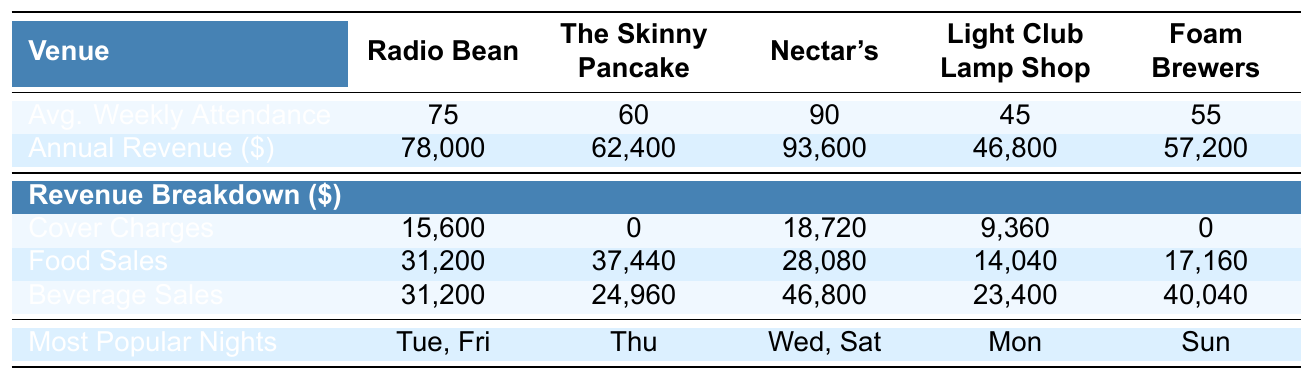What is the average weekly attendance at Nectar's? According to the table, the average weekly attendance for Nectar's is listed as 90 people.
Answer: 90 Which venue has the highest annual revenue? By comparing the annual revenue values listed in the table, Nectar's has the highest annual revenue at $93,600.
Answer: Nectar's How much revenue does Radio Bean make from food sales? The table indicates that Radio Bean generates $31,200 from food sales.
Answer: $31,200 Does The Skinny Pancake have revenue from cover charges? The data states that The Skinny Pancake has $0 in cover charges, indicating they do not collect any revenue from this source.
Answer: No What is the total beverage sales across all venues? To find the total beverage sales, we sum the values: 31,200 (Radio Bean) + 24,960 (The Skinny Pancake) + 46,800 (Nectar's) + 23,400 (Light Club Lamp Shop) + 40,040 (Foam Brewers) = 166,400.
Answer: $166,400 How does the average weekly attendance at Light Club Lamp Shop compare to Foam Brewers? The average weekly attendance at Light Club Lamp Shop is 45, while Foam Brewers has 55. So, Foam Brewers has a higher attendance by 10.
Answer: Foam Brewers has higher attendance by 10 Which venue has the least total revenue, including all revenue sources? The total revenue for Light Club Lamp Shop is calculated as $46,800, which is lower than the other venues.
Answer: Light Club Lamp Shop What is the average attendance across all venues? To calculate the average attendance, we add the weekly attendances: 75 + 60 + 90 + 45 + 55 = 325 and divide by 5 venues: 325 / 5 = 65.
Answer: 65 Which two nights are the most popular at Nectar's? The table shows that the most popular nights at Nectar's are Wednesday and Saturday.
Answer: Wednesday and Saturday Which venue has the highest revenue from beverage sales? Identifying the beverage sales in the table reveals Nectar's at $46,800 has the highest among the venues.
Answer: Nectar's What is the total annual revenue for venues that charge cover fees? The venues that charge cover fees are Radio Bean, Nectar's, and Light Club Lamp Shop. Their annual revenues are 78,000 + 93,600 + 46,800 = 218,400.
Answer: $218,400 